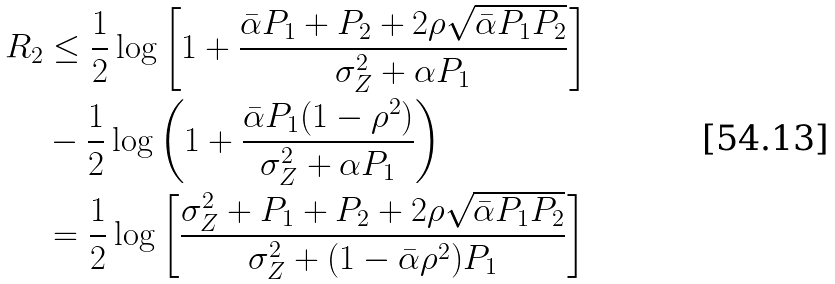Convert formula to latex. <formula><loc_0><loc_0><loc_500><loc_500>R _ { 2 } & \leq \frac { 1 } { 2 } \log \left [ 1 + \frac { \bar { \alpha } P _ { 1 } + P _ { 2 } + 2 \rho \sqrt { \bar { \alpha } P _ { 1 } P _ { 2 } } } { \sigma ^ { 2 } _ { Z } + \alpha P _ { 1 } } \right ] \\ & - \frac { 1 } { 2 } \log \left ( 1 + \frac { \bar { \alpha } P _ { 1 } ( 1 - \rho ^ { 2 } ) } { \sigma _ { Z } ^ { 2 } + \alpha P _ { 1 } } \right ) \\ & = \frac { 1 } { 2 } \log \left [ \frac { \sigma _ { Z } ^ { 2 } + P _ { 1 } + P _ { 2 } + 2 \rho \sqrt { \bar { \alpha } P _ { 1 } P _ { 2 } } } { \sigma _ { Z } ^ { 2 } + ( 1 - \bar { \alpha } \rho ^ { 2 } ) P _ { 1 } } \right ]</formula> 